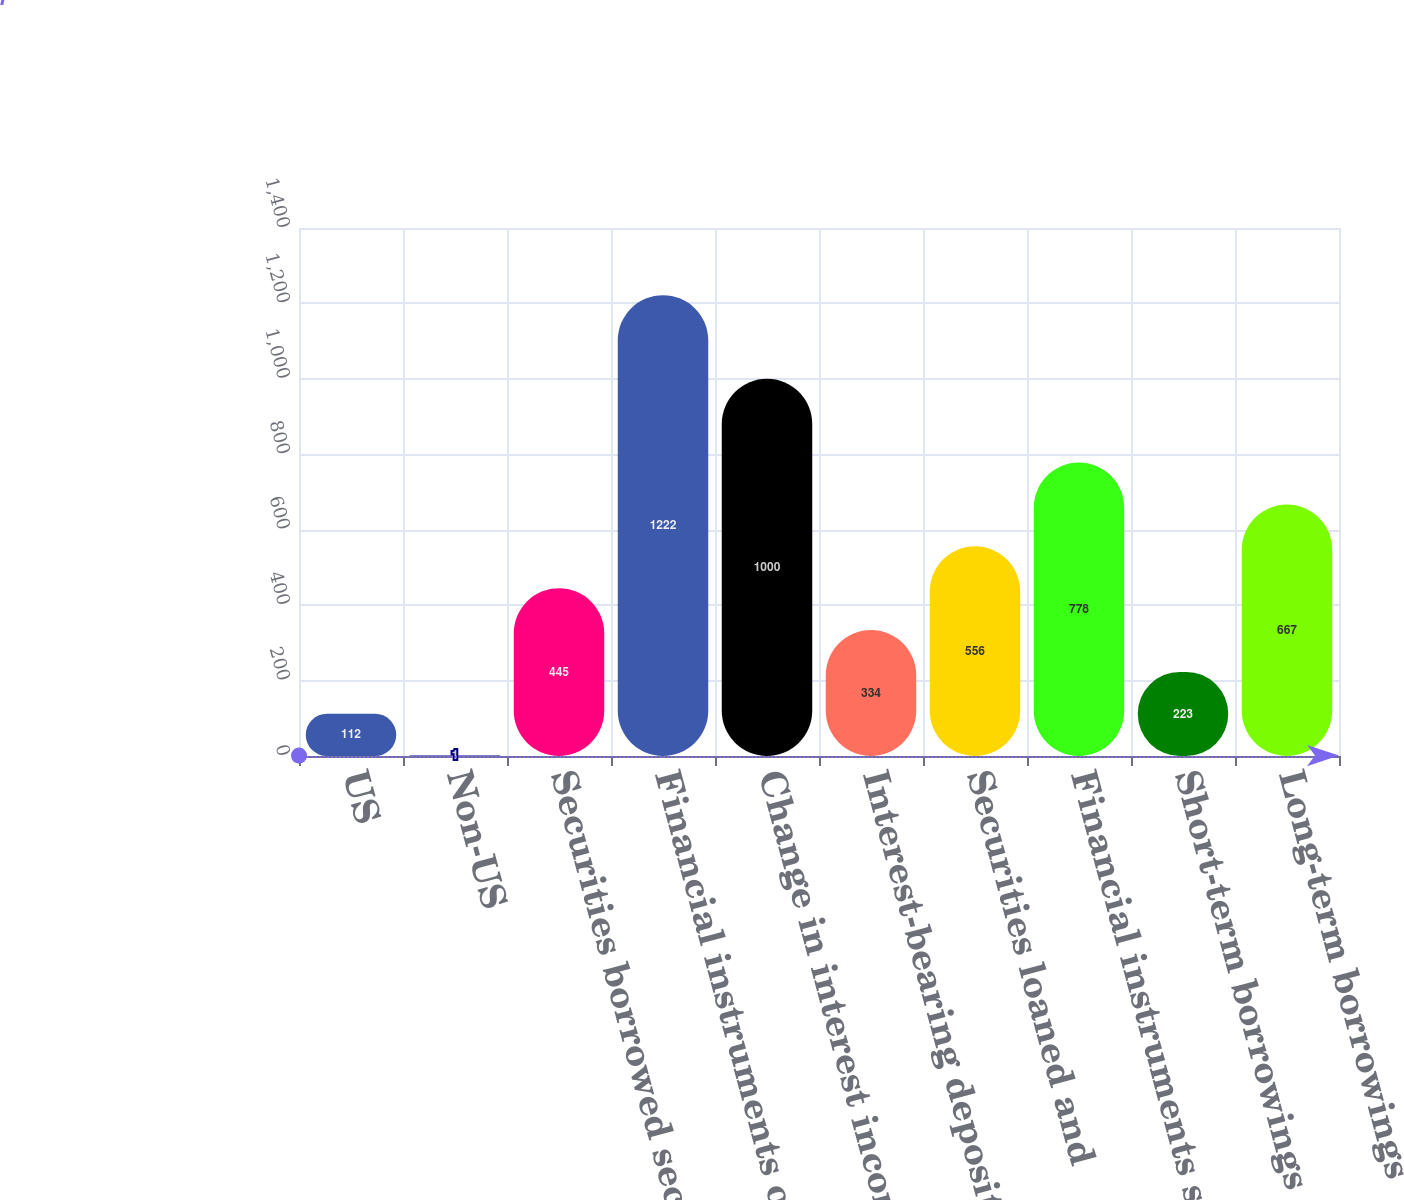<chart> <loc_0><loc_0><loc_500><loc_500><bar_chart><fcel>US<fcel>Non-US<fcel>Securities borrowed securities<fcel>Financial instruments owned at<fcel>Change in interest income<fcel>Interest-bearing deposits<fcel>Securities loaned and<fcel>Financial instruments sold but<fcel>Short-term borrowings<fcel>Long-term borrowings<nl><fcel>112<fcel>1<fcel>445<fcel>1222<fcel>1000<fcel>334<fcel>556<fcel>778<fcel>223<fcel>667<nl></chart> 